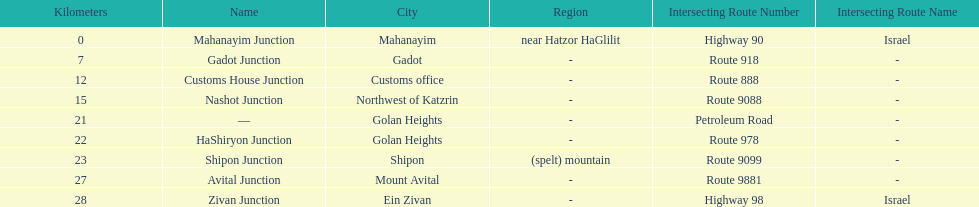Help me parse the entirety of this table. {'header': ['Kilometers', 'Name', 'City', 'Region', 'Intersecting Route Number', 'Intersecting Route Name'], 'rows': [['0', 'Mahanayim Junction', 'Mahanayim', 'near Hatzor HaGlilit', 'Highway 90', 'Israel'], ['7', 'Gadot Junction', 'Gadot', '-', 'Route 918', '-'], ['12', 'Customs House Junction', 'Customs office', '-', 'Route 888', '-'], ['15', 'Nashot Junction', 'Northwest of Katzrin', '-', 'Route 9088', '-'], ['21', '—', 'Golan Heights', '-', 'Petroleum Road', '-'], ['22', 'HaShiryon Junction', 'Golan Heights', '-', 'Route 978', '-'], ['23', 'Shipon Junction', 'Shipon', '(spelt) mountain', 'Route 9099', '-'], ['27', 'Avital Junction', 'Mount Avital', '-', 'Route 9881', '-'], ['28', 'Zivan Junction', 'Ein Zivan', '-', 'Highway 98', 'Israel']]} What is the total kilometers that separates the mahanayim junction and the shipon junction? 23. 